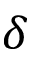<formula> <loc_0><loc_0><loc_500><loc_500>\delta</formula> 